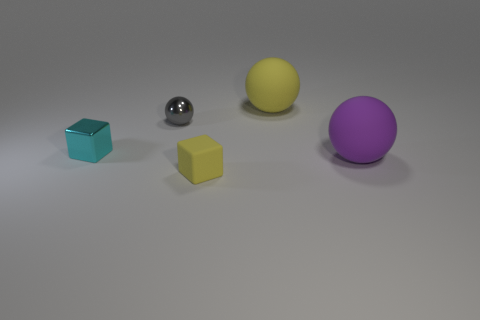What is the color of the tiny shiny thing that is the same shape as the big purple thing?
Your answer should be very brief. Gray. Do the gray object and the yellow thing that is to the right of the yellow rubber block have the same size?
Offer a terse response. No. The object that is behind the tiny cyan metallic cube and right of the yellow rubber block is what color?
Your answer should be very brief. Yellow. Are there any large things in front of the big thing in front of the cyan metal cube?
Give a very brief answer. No. Are there the same number of gray shiny objects to the right of the small yellow matte thing and small red spheres?
Give a very brief answer. Yes. What number of things are right of the cube behind the matte object that is left of the large yellow rubber object?
Ensure brevity in your answer.  4. Are there any gray balls that have the same size as the cyan object?
Ensure brevity in your answer.  Yes. Is the number of small metal balls behind the tiny shiny sphere less than the number of big spheres?
Your answer should be very brief. Yes. The block to the left of the tiny thing that is in front of the big object that is in front of the tiny gray metallic object is made of what material?
Ensure brevity in your answer.  Metal. Are there more tiny gray objects on the left side of the yellow rubber cube than objects left of the big yellow object?
Your response must be concise. No. 